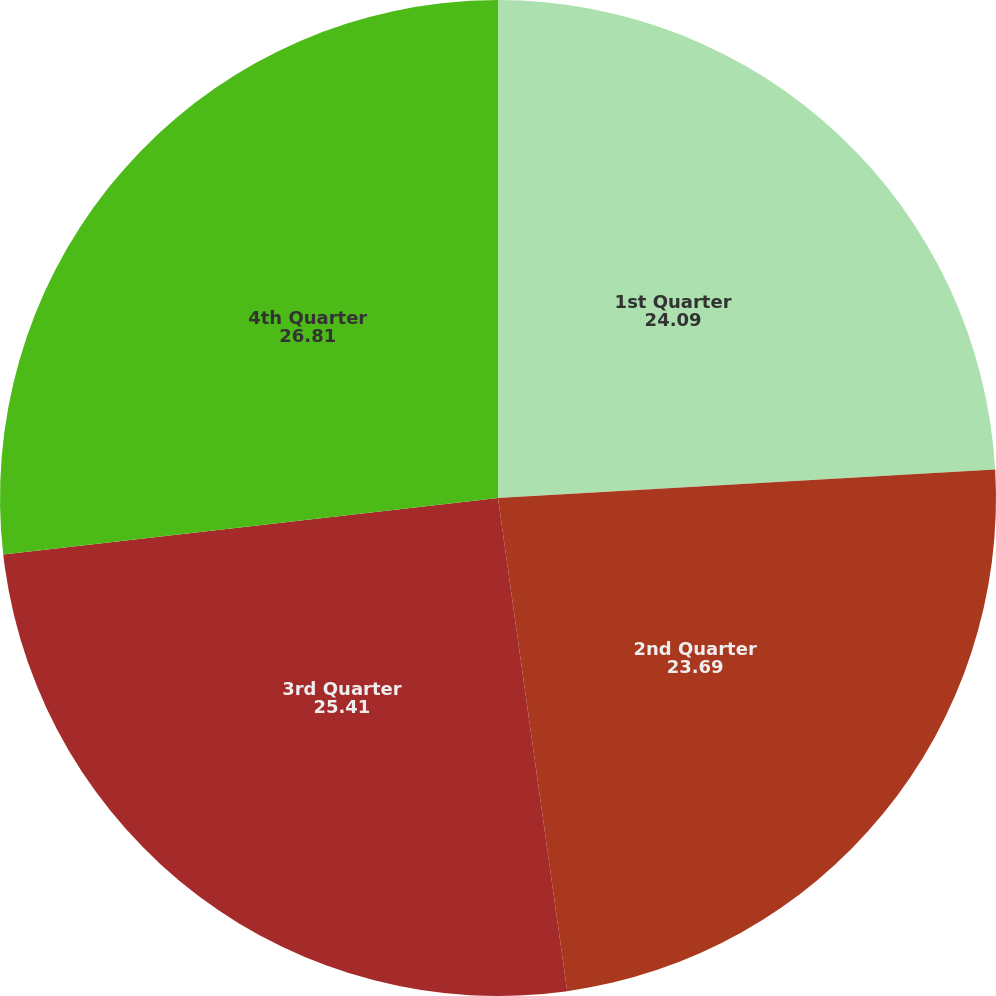Convert chart to OTSL. <chart><loc_0><loc_0><loc_500><loc_500><pie_chart><fcel>1st Quarter<fcel>2nd Quarter<fcel>3rd Quarter<fcel>4th Quarter<nl><fcel>24.09%<fcel>23.69%<fcel>25.41%<fcel>26.81%<nl></chart> 